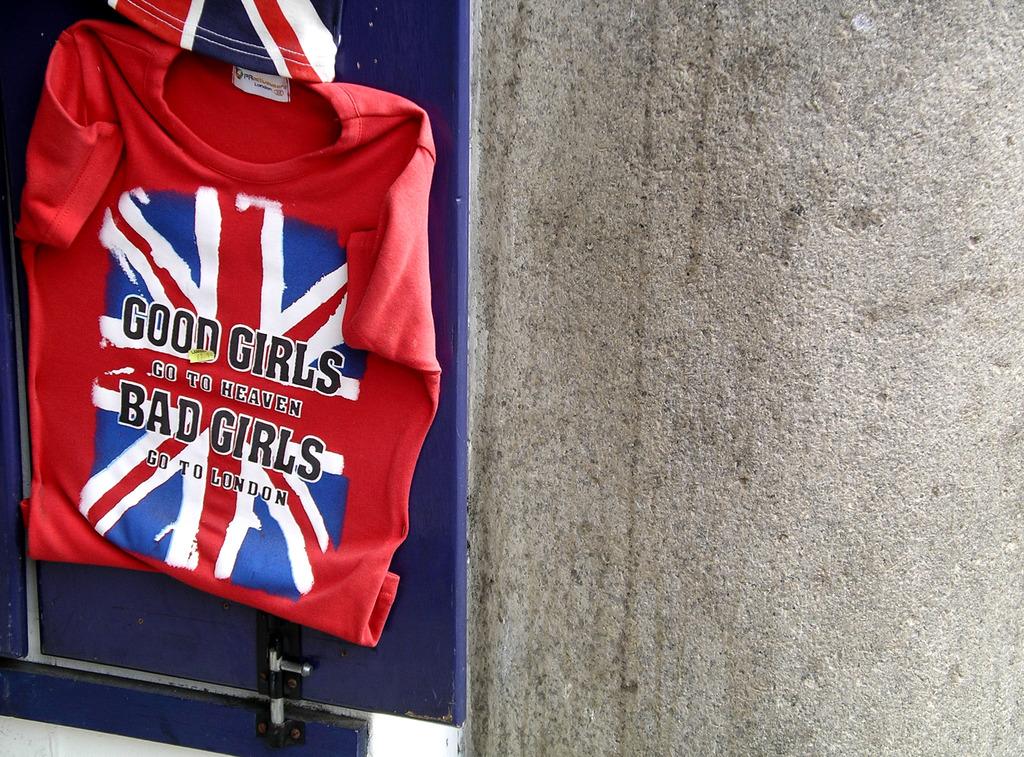What do good girls often do?
Give a very brief answer. Go to heaven. Where do bad girls go?
Provide a short and direct response. London. 